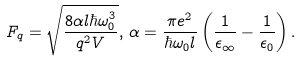Convert formula to latex. <formula><loc_0><loc_0><loc_500><loc_500>F _ { q } = \sqrt { \frac { 8 \alpha l \hbar { \omega } _ { 0 } ^ { 3 } } { q ^ { 2 } V } } , \, \alpha = \frac { \pi e ^ { 2 } } { \hbar { \omega } _ { 0 } l } \left ( \frac { 1 } { \epsilon _ { \infty } } - \frac { 1 } { \epsilon _ { 0 } } \right ) .</formula> 